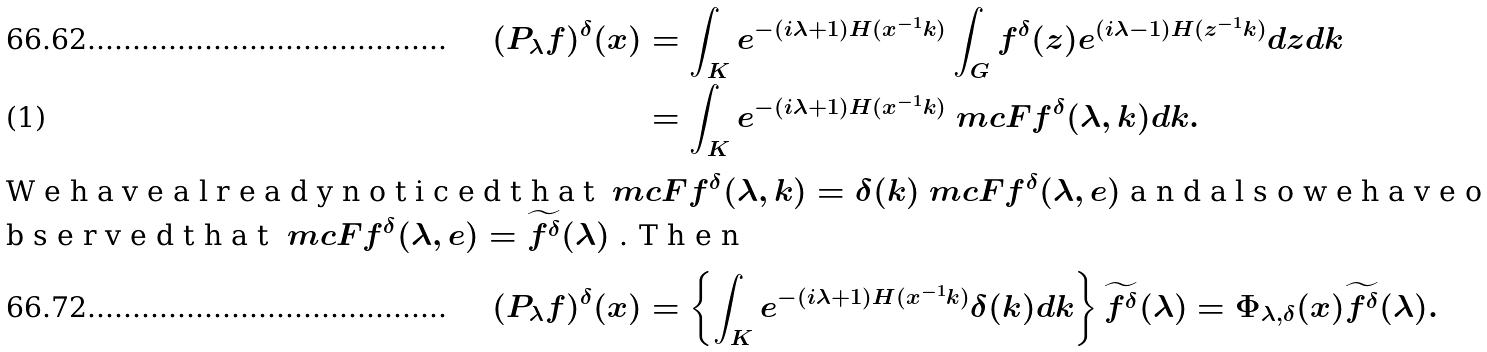Convert formula to latex. <formula><loc_0><loc_0><loc_500><loc_500>( P _ { \lambda } f ) ^ { \delta } ( x ) & = \int _ { K } e ^ { - ( i \lambda + 1 ) H ( x ^ { - 1 } k ) } \int _ { G } f ^ { \delta } ( z ) e ^ { ( i \lambda - 1 ) H ( z ^ { - 1 } k ) } d z d k \\ & = \int _ { K } e ^ { - ( i \lambda + 1 ) H ( x ^ { - 1 } k ) } \ m c F f ^ { \delta } ( \lambda , k ) d k . \intertext { W e h a v e a l r e a d y n o t i c e d t h a t $ \ m c F f ^ { \delta } ( \lambda , k ) = \delta ( k ) \ m c F f ^ { \delta } ( \lambda , e ) $ a n d a l s o w e h a v e o b s e r v e d t h a t $ \ m c F f ^ { \delta } ( \lambda , e ) = \widetilde { f ^ { \delta } } ( \lambda ) $ . T h e n } ( P _ { \lambda } f ) ^ { \delta } ( x ) & = \left \{ \int _ { K } e ^ { - ( i \lambda + 1 ) H ( x ^ { - 1 } k ) } \delta ( k ) d k \right \} \widetilde { f ^ { \delta } } ( \lambda ) = \Phi _ { \lambda , \delta } ( x ) \widetilde { f ^ { \delta } } ( \lambda ) .</formula> 